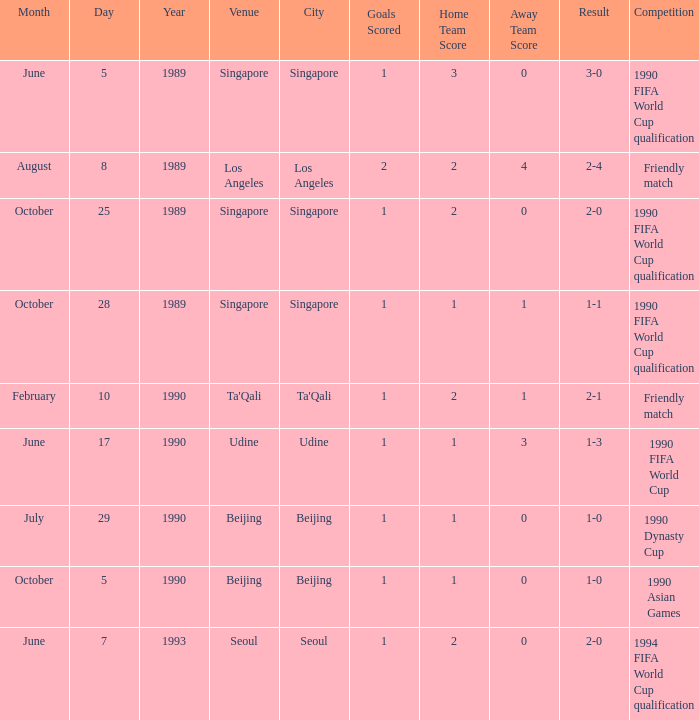What is the score of the match on October 5, 1990? 1 goal. 